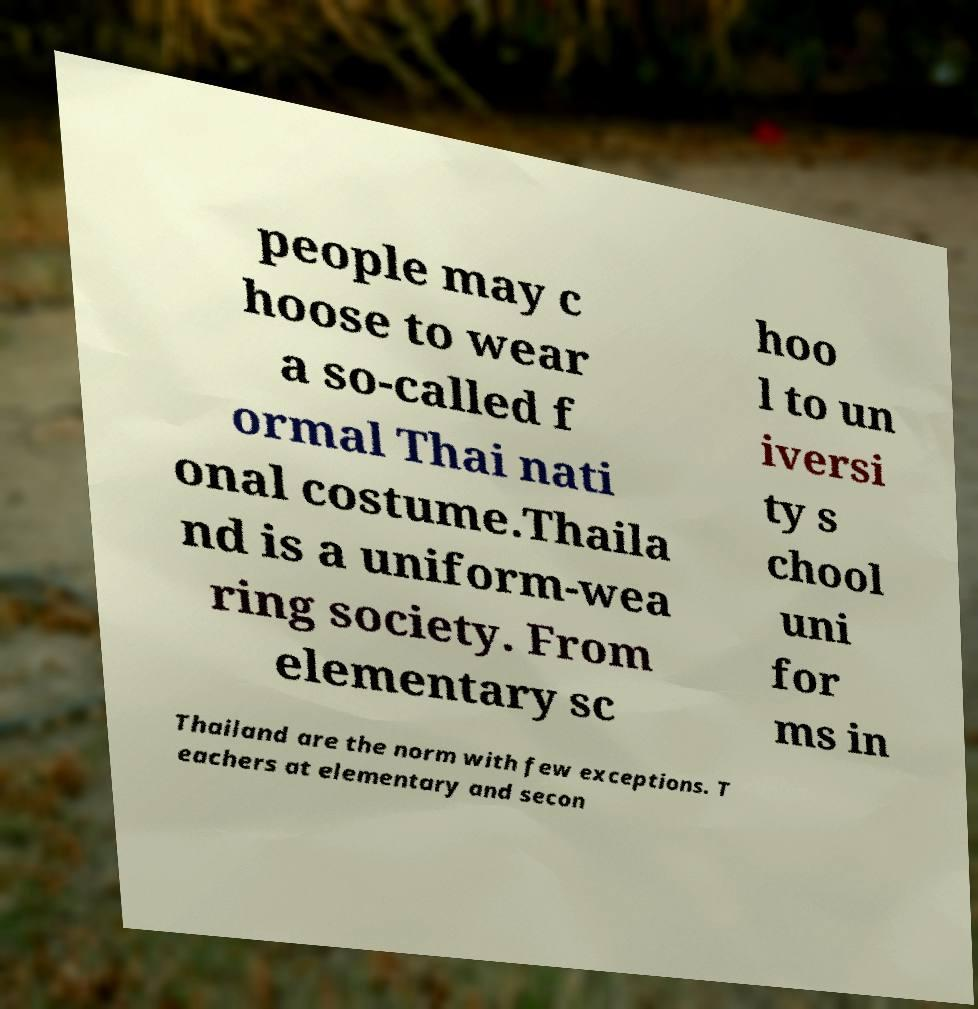Can you read and provide the text displayed in the image?This photo seems to have some interesting text. Can you extract and type it out for me? people may c hoose to wear a so-called f ormal Thai nati onal costume.Thaila nd is a uniform-wea ring society. From elementary sc hoo l to un iversi ty s chool uni for ms in Thailand are the norm with few exceptions. T eachers at elementary and secon 